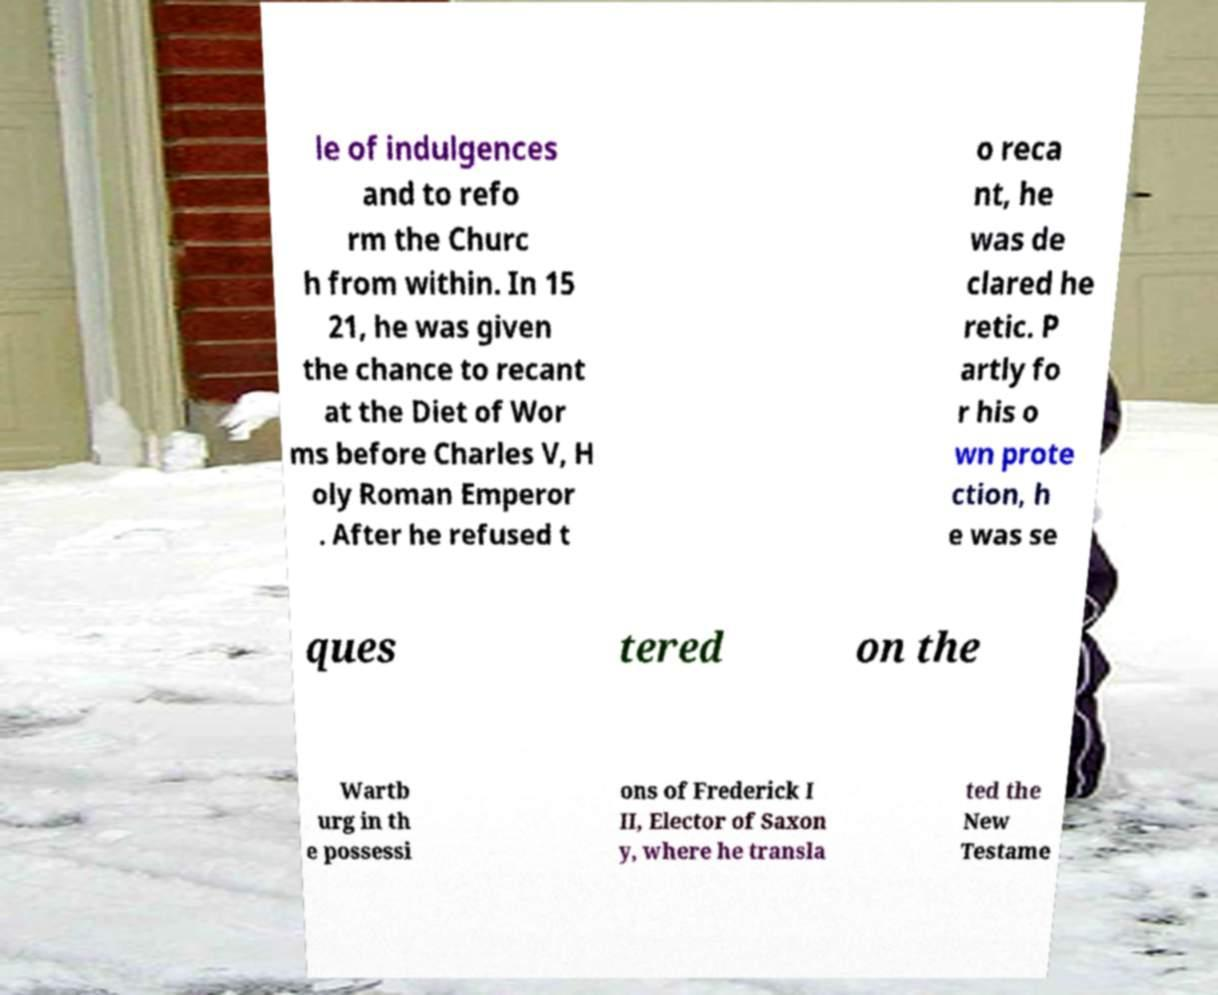Can you accurately transcribe the text from the provided image for me? le of indulgences and to refo rm the Churc h from within. In 15 21, he was given the chance to recant at the Diet of Wor ms before Charles V, H oly Roman Emperor . After he refused t o reca nt, he was de clared he retic. P artly fo r his o wn prote ction, h e was se ques tered on the Wartb urg in th e possessi ons of Frederick I II, Elector of Saxon y, where he transla ted the New Testame 